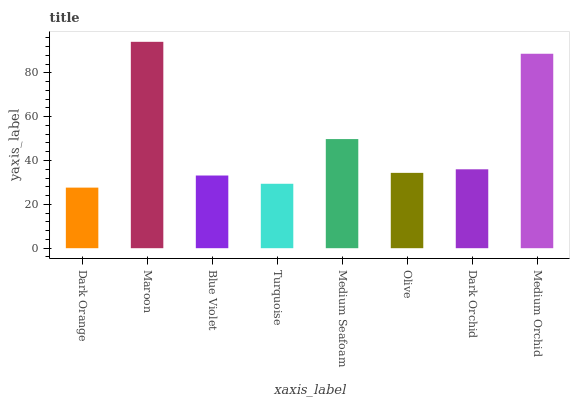Is Dark Orange the minimum?
Answer yes or no. Yes. Is Maroon the maximum?
Answer yes or no. Yes. Is Blue Violet the minimum?
Answer yes or no. No. Is Blue Violet the maximum?
Answer yes or no. No. Is Maroon greater than Blue Violet?
Answer yes or no. Yes. Is Blue Violet less than Maroon?
Answer yes or no. Yes. Is Blue Violet greater than Maroon?
Answer yes or no. No. Is Maroon less than Blue Violet?
Answer yes or no. No. Is Dark Orchid the high median?
Answer yes or no. Yes. Is Olive the low median?
Answer yes or no. Yes. Is Blue Violet the high median?
Answer yes or no. No. Is Blue Violet the low median?
Answer yes or no. No. 